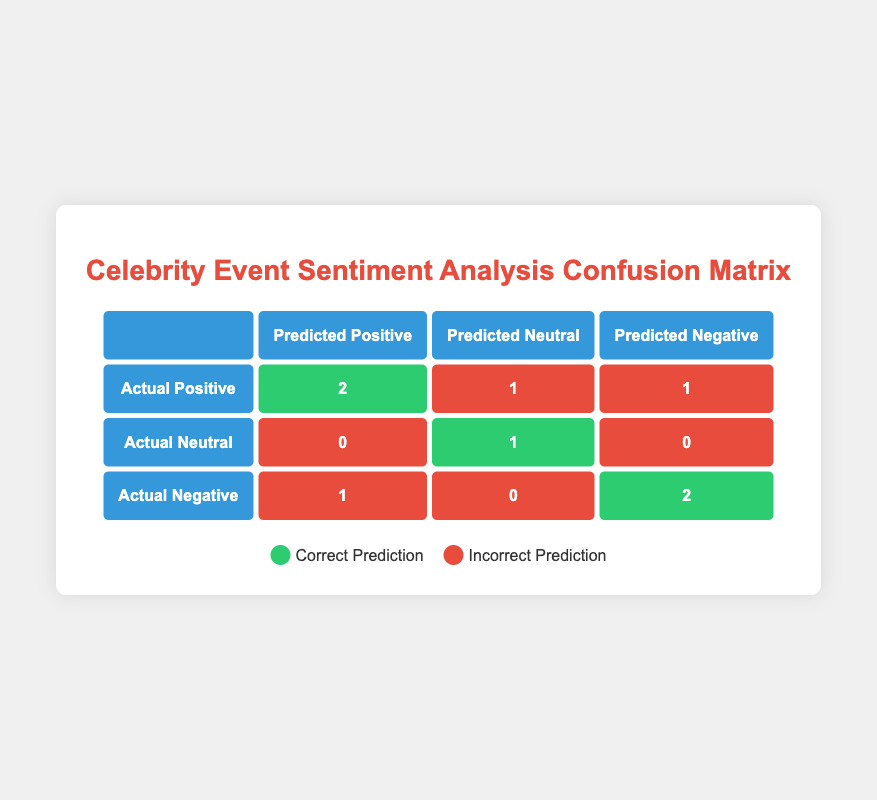What is the total number of celebrity events analyzed? There are eight celebrity events listed in the table.
Answer: 8 How many events were correctly predicted as Positive? Two events (Film Premiere and Concert Series Announcement) were predicted as Positive and were indeed Positive.
Answer: 2 What was the predicted sentiment for the Charity Gala Appearance? The predicted sentiment for the Charity Gala Appearance was Neutral.
Answer: Neutral Is it true that all the Negative events were predicted correctly? No, only the Social Media Scandal and Public Meltdown were predicted correctly as Negative. The Public Meltdown was predicted as Positive, thus it was incorrect.
Answer: No How many total Neutral sentiments were predicted across all events? One event (Fashion Week Showcase) had a predicted Neutral sentiment, which is counted in the Neutral predictions.
Answer: 1 What is the difference between the number of Actual Positive and Actual Neutral events? There are four Actual Positive events and one Actual Neutral event, therefore the difference is 4 - 1 = 3.
Answer: 3 Which sentiment had the highest number of correct predictions? Positive sentiment had the highest number of correct predictions, with a total of 2 events predicted correctly.
Answer: Positive How many events were incorrectly predicted as Neutral? One event (Charity Gala Appearance) was incorrectly predicted as Neutral when it was actually Positive, hence counted as incorrect.
Answer: 1 How many events were predicted as Negative overall? Three events were predicted as Negative (Public Meltdown, Social Media Scandal, and Reality Show Debut).
Answer: 3 What is the total number of incorrect predictions across all sentiments? The total number of incorrect predictions is 1 (for Positive) + 1 (for Neutral) + 1 (for Negative) = 3 incorrect predictions overall.
Answer: 3 